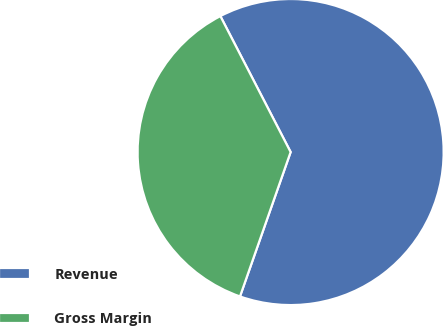Convert chart. <chart><loc_0><loc_0><loc_500><loc_500><pie_chart><fcel>Revenue<fcel>Gross Margin<nl><fcel>62.96%<fcel>37.04%<nl></chart> 